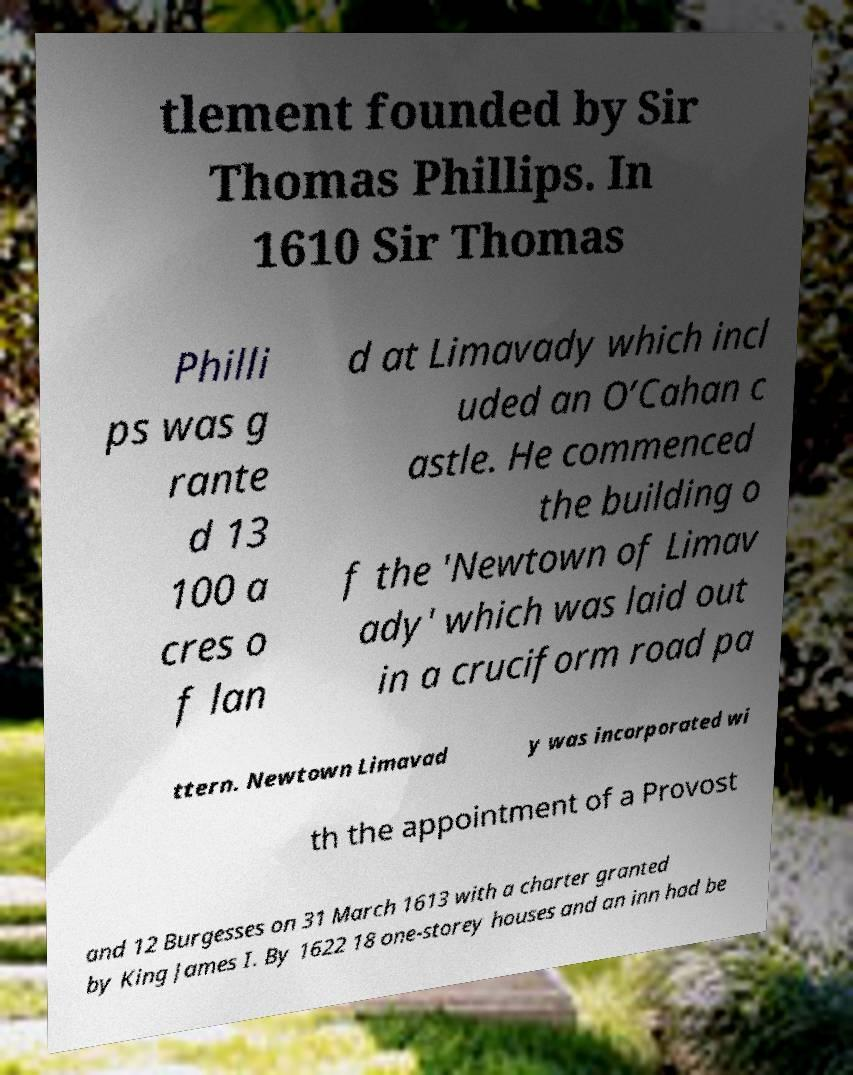Could you extract and type out the text from this image? tlement founded by Sir Thomas Phillips. In 1610 Sir Thomas Philli ps was g rante d 13 100 a cres o f lan d at Limavady which incl uded an O’Cahan c astle. He commenced the building o f the 'Newtown of Limav ady' which was laid out in a cruciform road pa ttern. Newtown Limavad y was incorporated wi th the appointment of a Provost and 12 Burgesses on 31 March 1613 with a charter granted by King James I. By 1622 18 one-storey houses and an inn had be 